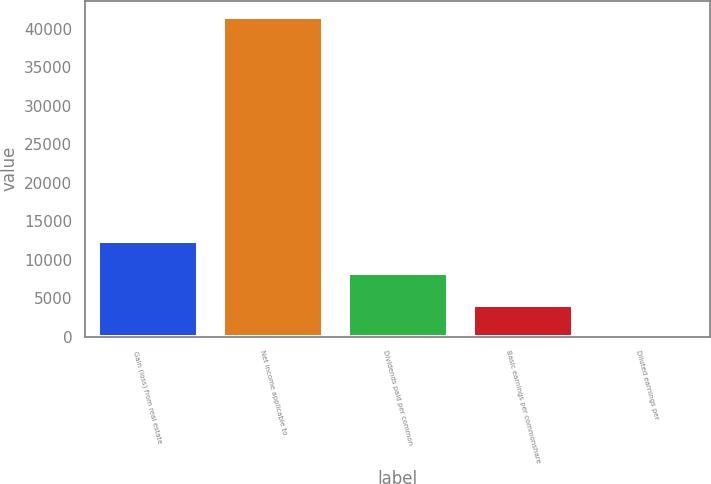Convert chart. <chart><loc_0><loc_0><loc_500><loc_500><bar_chart><fcel>Gain (loss) from real estate<fcel>Net income applicable to<fcel>Dividends paid per common<fcel>Basic earnings per commonshare<fcel>Diluted earnings per<nl><fcel>12465.8<fcel>41552<fcel>8310.65<fcel>4155.48<fcel>0.31<nl></chart> 